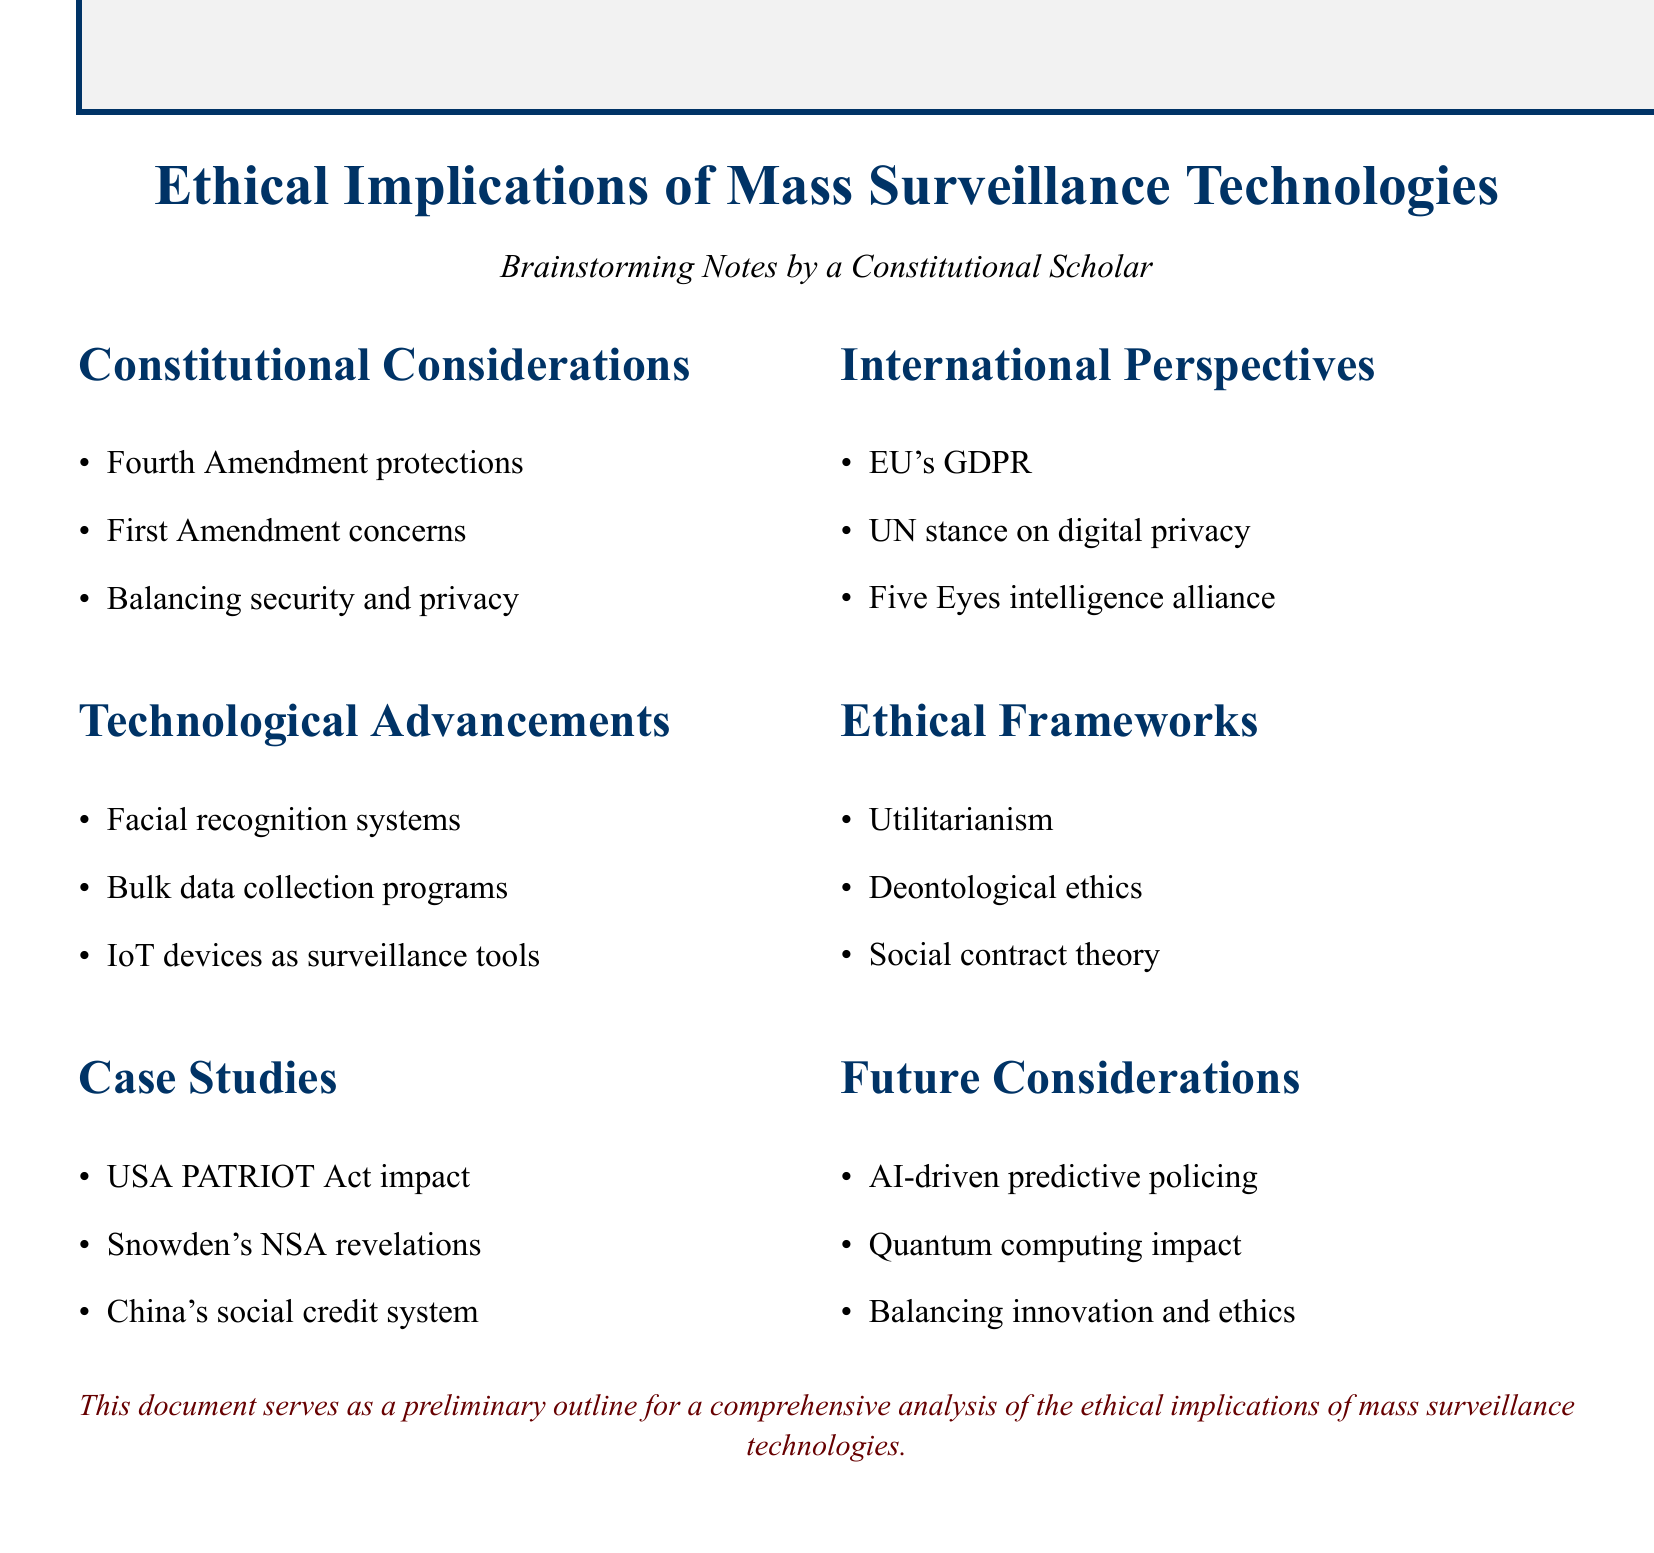What is the title of the document? The title is prominently displayed at the top of the document and states the primary focus on mass surveillance technologies.
Answer: Ethical Implications of Mass Surveillance Technologies What amendment addresses unreasonable searches and seizures? The Fourth Amendment is mentioned in relation to constitutional considerations regarding surveillance.
Answer: Fourth Amendment What system's impact on civil liberties is highlighted in the case studies? The document refers to the USA PATRIOT Act to discuss its impact on civil liberties.
Answer: USA PATRIOT Act Which ethical framework focuses on balancing societal benefits against individual privacy costs? The document lists utilitarianism as a framework concerned with the balance between societal benefits and privacy costs.
Answer: Utilitarianism What is the international regulation mentioned in the document regarding digital privacy? The EU's General Data Protection Regulation is referenced as a key perspective on international privacy regulations.
Answer: GDPR What technology is mentioned as a potential surveillance tool? The document cites Internet of Things (IoT) devices as tools that could be used for surveillance.
Answer: IoT devices What implication does quantum computing have according to the future considerations? The document highlights that quantum computing will impact encryption and data privacy among future considerations.
Answer: Encryption and data privacy Which alliance is mentioned in relation to global surveillance networks? The Five Eyes intelligence alliance is noted in the international perspectives section.
Answer: Five Eyes What do the ethical frameworks discussed include? The document lists utilitarianism, deontological ethics, and social contract theory as the ethical frameworks mentioned.
Answer: Utilitarianism, deontological ethics, social contract theory What is the primary focus of this document? The focus is on analyzing the ethical implications related to mass surveillance technologies.
Answer: Ethical implications of mass surveillance technologies 